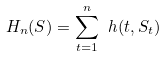<formula> <loc_0><loc_0><loc_500><loc_500>H _ { n } ( S ) = \sum _ { t = 1 } ^ { n } \ h ( t , S _ { t } )</formula> 